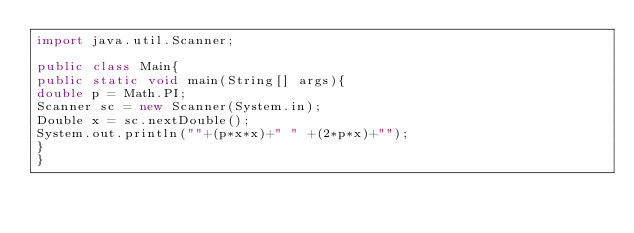Convert code to text. <code><loc_0><loc_0><loc_500><loc_500><_Java_>import java.util.Scanner;

public class Main{
public static void main(String[] args){
double p = Math.PI;
Scanner sc = new Scanner(System.in);
Double x = sc.nextDouble();
System.out.println(""+(p*x*x)+" " +(2*p*x)+"");
}
}</code> 